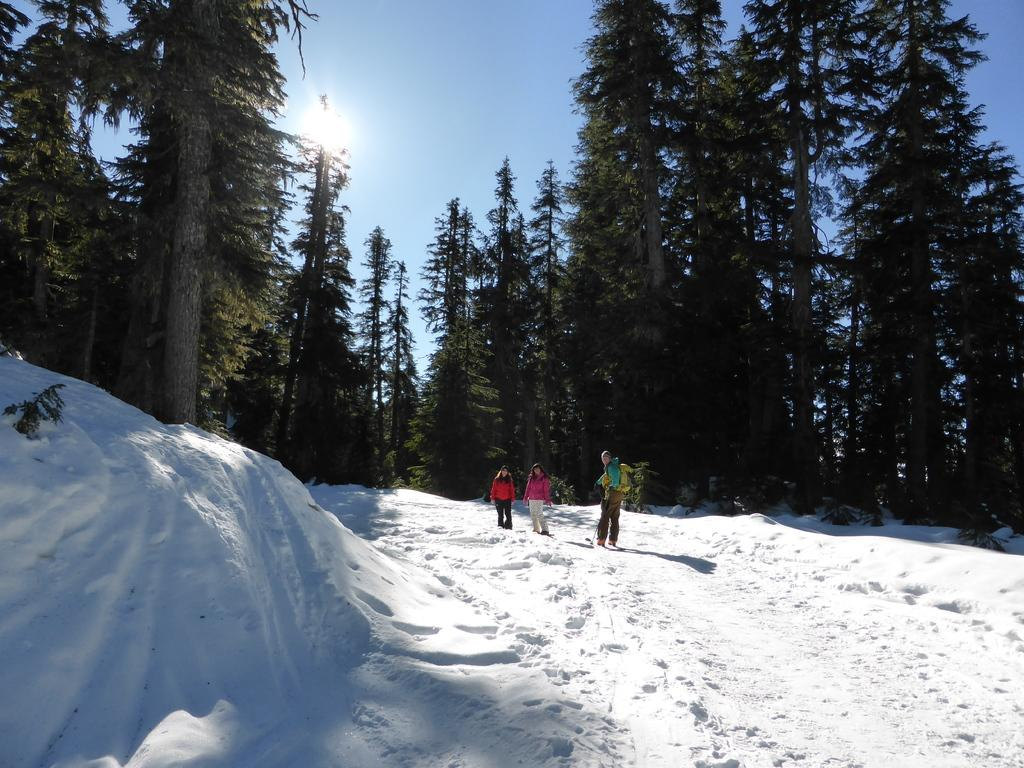How many people are in the image? There are three people in the image. What is the surface the people are standing on? The people are standing on snow. What can be seen in the background of the image? There are trees and the sky visible in the background of the image. What type of straw is being used to protect the people from the rainstorm in the image? There is no straw or rainstorm present in the image; the people are standing on snow with trees and the sky visible in the background. 